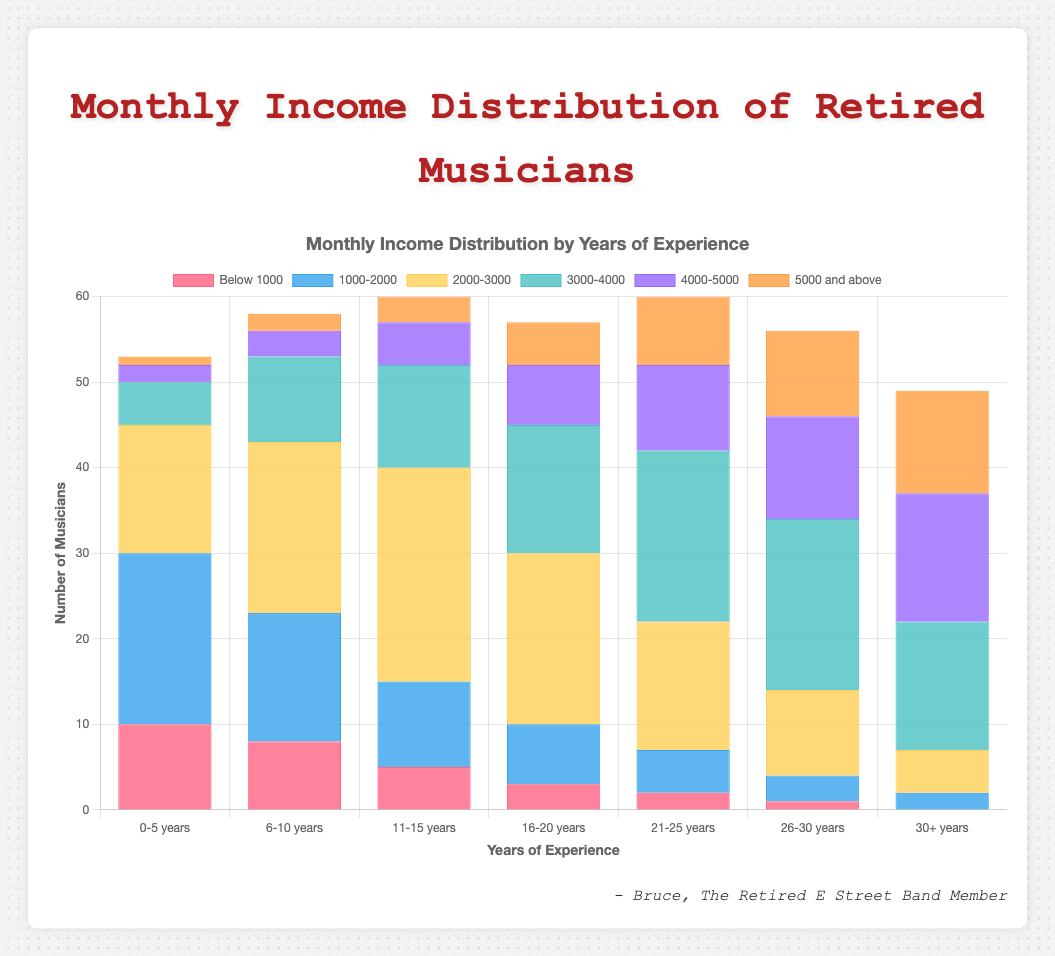Which experience group has the highest number of musicians earning below $1000 per month? Look for the bar corresponding to "Below 1000" in each experience group and find the tallest one. The 0-5 years group has the highest bar at 10 musicians.
Answer: 0-5 years Compare the number of musicians in the 2000-3000 income range for the 6-10 years and 16-20 years experience groups. Which group has more musicians? Find the heights of the bars corresponding to the "2000-3000" income range for both experience groups. The 6-10 years group has a height of 20, and the 16-20 years group has a height of 20, so they are equal.
Answer: 6-10 years, 16-20 years have the same What is the total number of musicians in the 30+ years experience group? Add the heights of all bars in the 30+ years experience group: 0 (Below 1000) + 2 (1000-2000) + 5 (2000-3000) + 15 (3000-4000) + 15 (4000-5000) + 12 (5000 and above) = 49.
Answer: 49 How many more musicians have an income of 3000-4000 in the 21-25 years group compared to the 6-10 years group? Subtract the number of musicians with 3000-4000 income in the 6-10 years group from that in the 21-25 years group: 20 (21-25 years) - 10 (6-10 years) = 10.
Answer: 10 more What visual attribute differentiates the income range of $5000 and above from the other income ranges in each experience group? Identify the common color of the bars representing the "$5000 and above" income range. They are represented by a distinctive color that is orange.
Answer: Orange color In which experience group is the income range of 1000-2000 the most prevalent compared to the other ranges within the same group? Examine each experience group and identify where the bar for "1000-2000" is the tallest compared to other ranges within the same group. For the 0-5 years group, "1000-2000" has the highest value with 20 musicians.
Answer: 0-5 years Which experience group has the largest range of income distribution (i.e., the most spread out)? Determine which group has both the lowest and highest categories with significant heights. The 30+ years group has bars in all income ranges from "Below 1000" to "5000 and above".
Answer: 30+ years Find the difference in the number of musicians earning 2000-3000 between 11-15 years and 26-30 years experience groups. Subtract the number of musicians earning 2000-3000 in the 26-30 years group from the 11-15 years group: 25 (11-15 years) - 10 (26-30 years) = 15.
Answer: 15 Which experience group has the highest peak in the 4000-5000 income range? Look for the tallest bar in the 4000-5000 category across all groups. The group 30+ years has the highest bar at 15 musicians.
Answer: 30+ years What percentage of musicians in the 26-30 years experience group earn above $3000 per month? Add up the numbers of musicians earning 3000-4000, 4000-5000, and 5000 and above in the 26-30 years group: 20 + 12 + 10 = 42. Total musicians in this group are 46. Calculate (42/46)*100 = approx 91.3%.
Answer: 91.3% 